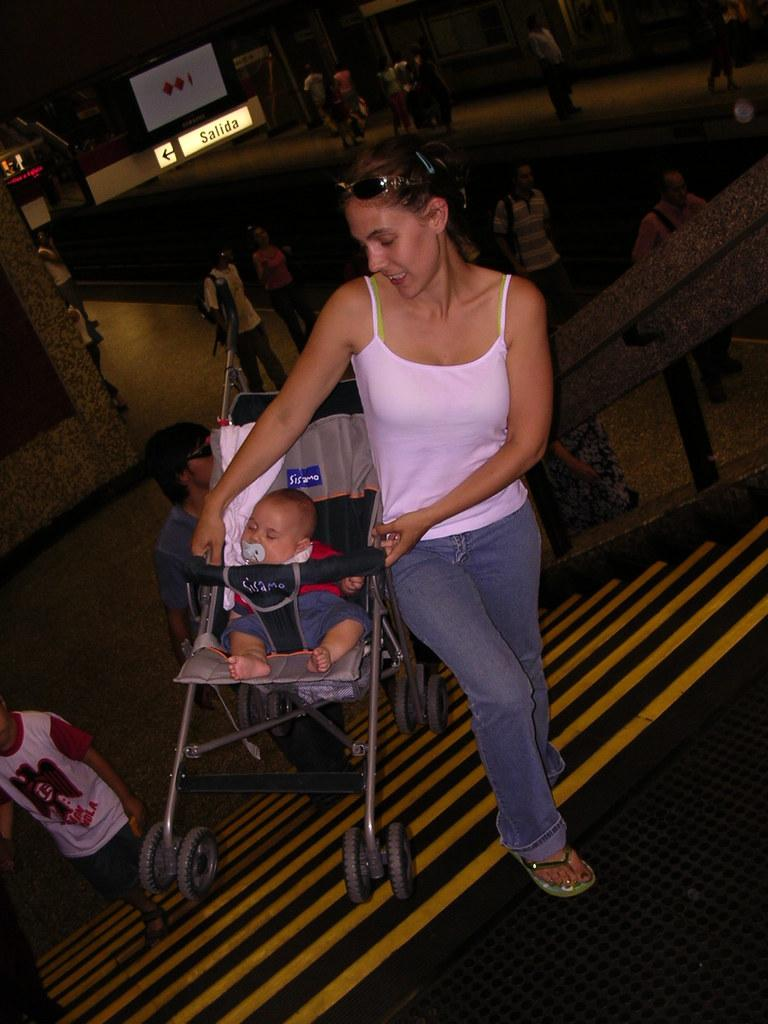<image>
Write a terse but informative summary of the picture. A woman pushes a baby in a Sisamo stroller. 